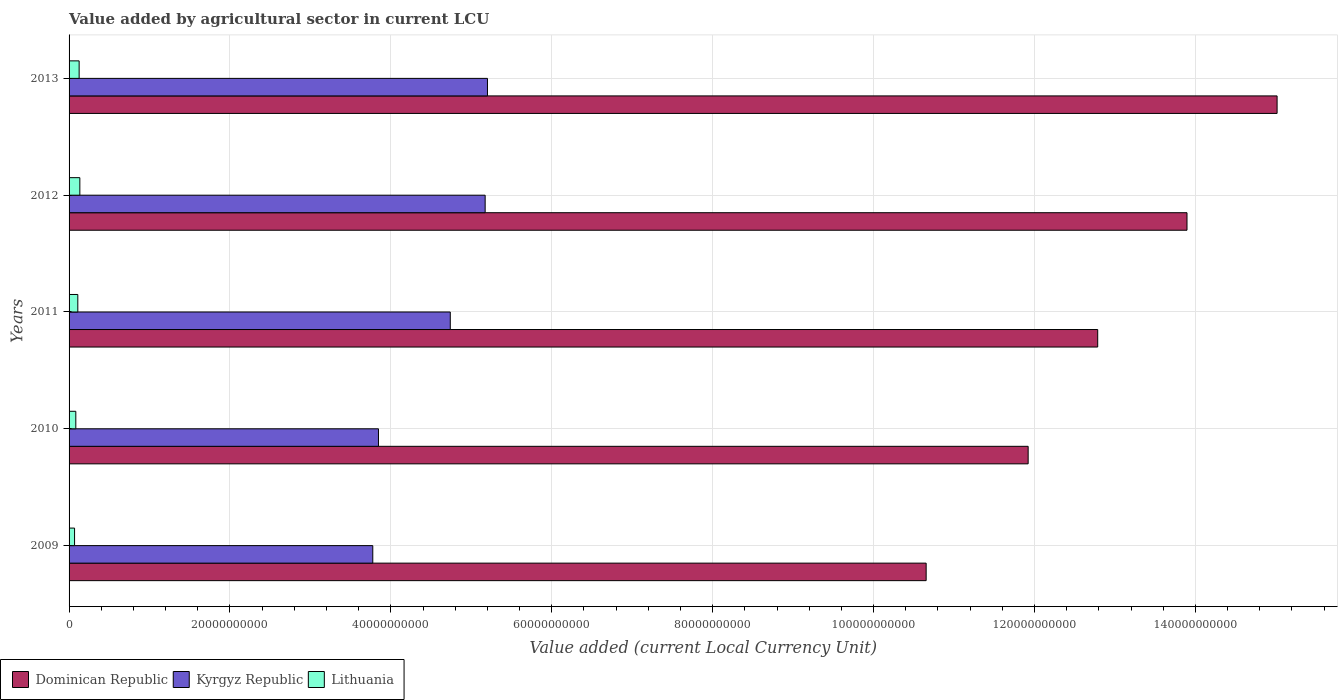How many different coloured bars are there?
Your response must be concise. 3. Are the number of bars per tick equal to the number of legend labels?
Offer a terse response. Yes. Are the number of bars on each tick of the Y-axis equal?
Make the answer very short. Yes. How many bars are there on the 4th tick from the bottom?
Your answer should be compact. 3. In how many cases, is the number of bars for a given year not equal to the number of legend labels?
Your answer should be very brief. 0. What is the value added by agricultural sector in Lithuania in 2010?
Offer a terse response. 8.38e+08. Across all years, what is the maximum value added by agricultural sector in Kyrgyz Republic?
Your answer should be compact. 5.20e+1. Across all years, what is the minimum value added by agricultural sector in Lithuania?
Provide a short and direct response. 6.82e+08. In which year was the value added by agricultural sector in Dominican Republic minimum?
Offer a very short reply. 2009. What is the total value added by agricultural sector in Dominican Republic in the graph?
Keep it short and to the point. 6.43e+11. What is the difference between the value added by agricultural sector in Dominican Republic in 2010 and that in 2011?
Your answer should be compact. -8.65e+09. What is the difference between the value added by agricultural sector in Dominican Republic in 2011 and the value added by agricultural sector in Lithuania in 2013?
Ensure brevity in your answer.  1.27e+11. What is the average value added by agricultural sector in Lithuania per year?
Provide a succinct answer. 1.04e+09. In the year 2011, what is the difference between the value added by agricultural sector in Lithuania and value added by agricultural sector in Dominican Republic?
Keep it short and to the point. -1.27e+11. What is the ratio of the value added by agricultural sector in Dominican Republic in 2011 to that in 2013?
Provide a short and direct response. 0.85. Is the value added by agricultural sector in Lithuania in 2009 less than that in 2011?
Offer a very short reply. Yes. Is the difference between the value added by agricultural sector in Lithuania in 2011 and 2012 greater than the difference between the value added by agricultural sector in Dominican Republic in 2011 and 2012?
Ensure brevity in your answer.  Yes. What is the difference between the highest and the second highest value added by agricultural sector in Kyrgyz Republic?
Provide a short and direct response. 2.88e+08. What is the difference between the highest and the lowest value added by agricultural sector in Dominican Republic?
Offer a terse response. 4.36e+1. Is the sum of the value added by agricultural sector in Dominican Republic in 2009 and 2010 greater than the maximum value added by agricultural sector in Kyrgyz Republic across all years?
Provide a succinct answer. Yes. What does the 2nd bar from the top in 2010 represents?
Give a very brief answer. Kyrgyz Republic. What does the 1st bar from the bottom in 2010 represents?
Keep it short and to the point. Dominican Republic. How many bars are there?
Your answer should be compact. 15. Are all the bars in the graph horizontal?
Provide a short and direct response. Yes. What is the difference between two consecutive major ticks on the X-axis?
Give a very brief answer. 2.00e+1. Are the values on the major ticks of X-axis written in scientific E-notation?
Offer a very short reply. No. Where does the legend appear in the graph?
Your answer should be very brief. Bottom left. What is the title of the graph?
Keep it short and to the point. Value added by agricultural sector in current LCU. Does "Switzerland" appear as one of the legend labels in the graph?
Keep it short and to the point. No. What is the label or title of the X-axis?
Your response must be concise. Value added (current Local Currency Unit). What is the label or title of the Y-axis?
Your answer should be very brief. Years. What is the Value added (current Local Currency Unit) in Dominican Republic in 2009?
Provide a short and direct response. 1.07e+11. What is the Value added (current Local Currency Unit) in Kyrgyz Republic in 2009?
Offer a very short reply. 3.78e+1. What is the Value added (current Local Currency Unit) of Lithuania in 2009?
Keep it short and to the point. 6.82e+08. What is the Value added (current Local Currency Unit) of Dominican Republic in 2010?
Make the answer very short. 1.19e+11. What is the Value added (current Local Currency Unit) of Kyrgyz Republic in 2010?
Your answer should be compact. 3.85e+1. What is the Value added (current Local Currency Unit) of Lithuania in 2010?
Offer a very short reply. 8.38e+08. What is the Value added (current Local Currency Unit) of Dominican Republic in 2011?
Give a very brief answer. 1.28e+11. What is the Value added (current Local Currency Unit) in Kyrgyz Republic in 2011?
Your answer should be compact. 4.74e+1. What is the Value added (current Local Currency Unit) of Lithuania in 2011?
Your answer should be compact. 1.09e+09. What is the Value added (current Local Currency Unit) in Dominican Republic in 2012?
Provide a short and direct response. 1.39e+11. What is the Value added (current Local Currency Unit) of Kyrgyz Republic in 2012?
Make the answer very short. 5.17e+1. What is the Value added (current Local Currency Unit) of Lithuania in 2012?
Ensure brevity in your answer.  1.34e+09. What is the Value added (current Local Currency Unit) in Dominican Republic in 2013?
Ensure brevity in your answer.  1.50e+11. What is the Value added (current Local Currency Unit) of Kyrgyz Republic in 2013?
Keep it short and to the point. 5.20e+1. What is the Value added (current Local Currency Unit) of Lithuania in 2013?
Ensure brevity in your answer.  1.25e+09. Across all years, what is the maximum Value added (current Local Currency Unit) of Dominican Republic?
Offer a terse response. 1.50e+11. Across all years, what is the maximum Value added (current Local Currency Unit) of Kyrgyz Republic?
Offer a terse response. 5.20e+1. Across all years, what is the maximum Value added (current Local Currency Unit) in Lithuania?
Offer a terse response. 1.34e+09. Across all years, what is the minimum Value added (current Local Currency Unit) of Dominican Republic?
Offer a terse response. 1.07e+11. Across all years, what is the minimum Value added (current Local Currency Unit) in Kyrgyz Republic?
Ensure brevity in your answer.  3.78e+1. Across all years, what is the minimum Value added (current Local Currency Unit) in Lithuania?
Your answer should be compact. 6.82e+08. What is the total Value added (current Local Currency Unit) of Dominican Republic in the graph?
Provide a succinct answer. 6.43e+11. What is the total Value added (current Local Currency Unit) of Kyrgyz Republic in the graph?
Make the answer very short. 2.27e+11. What is the total Value added (current Local Currency Unit) in Lithuania in the graph?
Make the answer very short. 5.20e+09. What is the difference between the Value added (current Local Currency Unit) in Dominican Republic in 2009 and that in 2010?
Offer a very short reply. -1.27e+1. What is the difference between the Value added (current Local Currency Unit) in Kyrgyz Republic in 2009 and that in 2010?
Your answer should be very brief. -7.08e+08. What is the difference between the Value added (current Local Currency Unit) of Lithuania in 2009 and that in 2010?
Provide a succinct answer. -1.56e+08. What is the difference between the Value added (current Local Currency Unit) in Dominican Republic in 2009 and that in 2011?
Your answer should be compact. -2.13e+1. What is the difference between the Value added (current Local Currency Unit) of Kyrgyz Republic in 2009 and that in 2011?
Your response must be concise. -9.63e+09. What is the difference between the Value added (current Local Currency Unit) of Lithuania in 2009 and that in 2011?
Provide a succinct answer. -4.04e+08. What is the difference between the Value added (current Local Currency Unit) in Dominican Republic in 2009 and that in 2012?
Offer a very short reply. -3.24e+1. What is the difference between the Value added (current Local Currency Unit) in Kyrgyz Republic in 2009 and that in 2012?
Make the answer very short. -1.40e+1. What is the difference between the Value added (current Local Currency Unit) of Lithuania in 2009 and that in 2012?
Give a very brief answer. -6.58e+08. What is the difference between the Value added (current Local Currency Unit) of Dominican Republic in 2009 and that in 2013?
Your response must be concise. -4.36e+1. What is the difference between the Value added (current Local Currency Unit) in Kyrgyz Republic in 2009 and that in 2013?
Your response must be concise. -1.43e+1. What is the difference between the Value added (current Local Currency Unit) of Lithuania in 2009 and that in 2013?
Your answer should be compact. -5.69e+08. What is the difference between the Value added (current Local Currency Unit) in Dominican Republic in 2010 and that in 2011?
Make the answer very short. -8.65e+09. What is the difference between the Value added (current Local Currency Unit) of Kyrgyz Republic in 2010 and that in 2011?
Give a very brief answer. -8.93e+09. What is the difference between the Value added (current Local Currency Unit) in Lithuania in 2010 and that in 2011?
Your response must be concise. -2.48e+08. What is the difference between the Value added (current Local Currency Unit) of Dominican Republic in 2010 and that in 2012?
Keep it short and to the point. -1.97e+1. What is the difference between the Value added (current Local Currency Unit) in Kyrgyz Republic in 2010 and that in 2012?
Your answer should be compact. -1.33e+1. What is the difference between the Value added (current Local Currency Unit) of Lithuania in 2010 and that in 2012?
Ensure brevity in your answer.  -5.02e+08. What is the difference between the Value added (current Local Currency Unit) of Dominican Republic in 2010 and that in 2013?
Make the answer very short. -3.09e+1. What is the difference between the Value added (current Local Currency Unit) of Kyrgyz Republic in 2010 and that in 2013?
Make the answer very short. -1.35e+1. What is the difference between the Value added (current Local Currency Unit) of Lithuania in 2010 and that in 2013?
Give a very brief answer. -4.13e+08. What is the difference between the Value added (current Local Currency Unit) of Dominican Republic in 2011 and that in 2012?
Keep it short and to the point. -1.11e+1. What is the difference between the Value added (current Local Currency Unit) of Kyrgyz Republic in 2011 and that in 2012?
Give a very brief answer. -4.33e+09. What is the difference between the Value added (current Local Currency Unit) in Lithuania in 2011 and that in 2012?
Give a very brief answer. -2.53e+08. What is the difference between the Value added (current Local Currency Unit) in Dominican Republic in 2011 and that in 2013?
Offer a very short reply. -2.23e+1. What is the difference between the Value added (current Local Currency Unit) in Kyrgyz Republic in 2011 and that in 2013?
Your answer should be compact. -4.62e+09. What is the difference between the Value added (current Local Currency Unit) in Lithuania in 2011 and that in 2013?
Your answer should be very brief. -1.65e+08. What is the difference between the Value added (current Local Currency Unit) of Dominican Republic in 2012 and that in 2013?
Your response must be concise. -1.12e+1. What is the difference between the Value added (current Local Currency Unit) of Kyrgyz Republic in 2012 and that in 2013?
Give a very brief answer. -2.88e+08. What is the difference between the Value added (current Local Currency Unit) of Lithuania in 2012 and that in 2013?
Your answer should be compact. 8.86e+07. What is the difference between the Value added (current Local Currency Unit) of Dominican Republic in 2009 and the Value added (current Local Currency Unit) of Kyrgyz Republic in 2010?
Give a very brief answer. 6.81e+1. What is the difference between the Value added (current Local Currency Unit) in Dominican Republic in 2009 and the Value added (current Local Currency Unit) in Lithuania in 2010?
Your answer should be compact. 1.06e+11. What is the difference between the Value added (current Local Currency Unit) in Kyrgyz Republic in 2009 and the Value added (current Local Currency Unit) in Lithuania in 2010?
Keep it short and to the point. 3.69e+1. What is the difference between the Value added (current Local Currency Unit) in Dominican Republic in 2009 and the Value added (current Local Currency Unit) in Kyrgyz Republic in 2011?
Ensure brevity in your answer.  5.92e+1. What is the difference between the Value added (current Local Currency Unit) in Dominican Republic in 2009 and the Value added (current Local Currency Unit) in Lithuania in 2011?
Your answer should be compact. 1.05e+11. What is the difference between the Value added (current Local Currency Unit) in Kyrgyz Republic in 2009 and the Value added (current Local Currency Unit) in Lithuania in 2011?
Make the answer very short. 3.67e+1. What is the difference between the Value added (current Local Currency Unit) of Dominican Republic in 2009 and the Value added (current Local Currency Unit) of Kyrgyz Republic in 2012?
Provide a short and direct response. 5.48e+1. What is the difference between the Value added (current Local Currency Unit) in Dominican Republic in 2009 and the Value added (current Local Currency Unit) in Lithuania in 2012?
Make the answer very short. 1.05e+11. What is the difference between the Value added (current Local Currency Unit) in Kyrgyz Republic in 2009 and the Value added (current Local Currency Unit) in Lithuania in 2012?
Your response must be concise. 3.64e+1. What is the difference between the Value added (current Local Currency Unit) of Dominican Republic in 2009 and the Value added (current Local Currency Unit) of Kyrgyz Republic in 2013?
Your answer should be very brief. 5.45e+1. What is the difference between the Value added (current Local Currency Unit) in Dominican Republic in 2009 and the Value added (current Local Currency Unit) in Lithuania in 2013?
Provide a succinct answer. 1.05e+11. What is the difference between the Value added (current Local Currency Unit) in Kyrgyz Republic in 2009 and the Value added (current Local Currency Unit) in Lithuania in 2013?
Ensure brevity in your answer.  3.65e+1. What is the difference between the Value added (current Local Currency Unit) of Dominican Republic in 2010 and the Value added (current Local Currency Unit) of Kyrgyz Republic in 2011?
Offer a terse response. 7.18e+1. What is the difference between the Value added (current Local Currency Unit) in Dominican Republic in 2010 and the Value added (current Local Currency Unit) in Lithuania in 2011?
Offer a terse response. 1.18e+11. What is the difference between the Value added (current Local Currency Unit) of Kyrgyz Republic in 2010 and the Value added (current Local Currency Unit) of Lithuania in 2011?
Give a very brief answer. 3.74e+1. What is the difference between the Value added (current Local Currency Unit) in Dominican Republic in 2010 and the Value added (current Local Currency Unit) in Kyrgyz Republic in 2012?
Ensure brevity in your answer.  6.75e+1. What is the difference between the Value added (current Local Currency Unit) of Dominican Republic in 2010 and the Value added (current Local Currency Unit) of Lithuania in 2012?
Your answer should be compact. 1.18e+11. What is the difference between the Value added (current Local Currency Unit) in Kyrgyz Republic in 2010 and the Value added (current Local Currency Unit) in Lithuania in 2012?
Offer a terse response. 3.71e+1. What is the difference between the Value added (current Local Currency Unit) in Dominican Republic in 2010 and the Value added (current Local Currency Unit) in Kyrgyz Republic in 2013?
Offer a terse response. 6.72e+1. What is the difference between the Value added (current Local Currency Unit) of Dominican Republic in 2010 and the Value added (current Local Currency Unit) of Lithuania in 2013?
Provide a short and direct response. 1.18e+11. What is the difference between the Value added (current Local Currency Unit) of Kyrgyz Republic in 2010 and the Value added (current Local Currency Unit) of Lithuania in 2013?
Your answer should be compact. 3.72e+1. What is the difference between the Value added (current Local Currency Unit) in Dominican Republic in 2011 and the Value added (current Local Currency Unit) in Kyrgyz Republic in 2012?
Keep it short and to the point. 7.61e+1. What is the difference between the Value added (current Local Currency Unit) of Dominican Republic in 2011 and the Value added (current Local Currency Unit) of Lithuania in 2012?
Your response must be concise. 1.27e+11. What is the difference between the Value added (current Local Currency Unit) in Kyrgyz Republic in 2011 and the Value added (current Local Currency Unit) in Lithuania in 2012?
Your answer should be compact. 4.60e+1. What is the difference between the Value added (current Local Currency Unit) in Dominican Republic in 2011 and the Value added (current Local Currency Unit) in Kyrgyz Republic in 2013?
Ensure brevity in your answer.  7.59e+1. What is the difference between the Value added (current Local Currency Unit) in Dominican Republic in 2011 and the Value added (current Local Currency Unit) in Lithuania in 2013?
Offer a very short reply. 1.27e+11. What is the difference between the Value added (current Local Currency Unit) in Kyrgyz Republic in 2011 and the Value added (current Local Currency Unit) in Lithuania in 2013?
Make the answer very short. 4.61e+1. What is the difference between the Value added (current Local Currency Unit) in Dominican Republic in 2012 and the Value added (current Local Currency Unit) in Kyrgyz Republic in 2013?
Offer a very short reply. 8.70e+1. What is the difference between the Value added (current Local Currency Unit) in Dominican Republic in 2012 and the Value added (current Local Currency Unit) in Lithuania in 2013?
Make the answer very short. 1.38e+11. What is the difference between the Value added (current Local Currency Unit) of Kyrgyz Republic in 2012 and the Value added (current Local Currency Unit) of Lithuania in 2013?
Your answer should be compact. 5.05e+1. What is the average Value added (current Local Currency Unit) of Dominican Republic per year?
Provide a short and direct response. 1.29e+11. What is the average Value added (current Local Currency Unit) of Kyrgyz Republic per year?
Offer a very short reply. 4.55e+1. What is the average Value added (current Local Currency Unit) of Lithuania per year?
Provide a short and direct response. 1.04e+09. In the year 2009, what is the difference between the Value added (current Local Currency Unit) in Dominican Republic and Value added (current Local Currency Unit) in Kyrgyz Republic?
Your answer should be compact. 6.88e+1. In the year 2009, what is the difference between the Value added (current Local Currency Unit) in Dominican Republic and Value added (current Local Currency Unit) in Lithuania?
Your answer should be very brief. 1.06e+11. In the year 2009, what is the difference between the Value added (current Local Currency Unit) in Kyrgyz Republic and Value added (current Local Currency Unit) in Lithuania?
Provide a short and direct response. 3.71e+1. In the year 2010, what is the difference between the Value added (current Local Currency Unit) of Dominican Republic and Value added (current Local Currency Unit) of Kyrgyz Republic?
Offer a terse response. 8.08e+1. In the year 2010, what is the difference between the Value added (current Local Currency Unit) in Dominican Republic and Value added (current Local Currency Unit) in Lithuania?
Give a very brief answer. 1.18e+11. In the year 2010, what is the difference between the Value added (current Local Currency Unit) of Kyrgyz Republic and Value added (current Local Currency Unit) of Lithuania?
Provide a succinct answer. 3.76e+1. In the year 2011, what is the difference between the Value added (current Local Currency Unit) of Dominican Republic and Value added (current Local Currency Unit) of Kyrgyz Republic?
Your answer should be very brief. 8.05e+1. In the year 2011, what is the difference between the Value added (current Local Currency Unit) in Dominican Republic and Value added (current Local Currency Unit) in Lithuania?
Make the answer very short. 1.27e+11. In the year 2011, what is the difference between the Value added (current Local Currency Unit) of Kyrgyz Republic and Value added (current Local Currency Unit) of Lithuania?
Give a very brief answer. 4.63e+1. In the year 2012, what is the difference between the Value added (current Local Currency Unit) in Dominican Republic and Value added (current Local Currency Unit) in Kyrgyz Republic?
Ensure brevity in your answer.  8.72e+1. In the year 2012, what is the difference between the Value added (current Local Currency Unit) in Dominican Republic and Value added (current Local Currency Unit) in Lithuania?
Keep it short and to the point. 1.38e+11. In the year 2012, what is the difference between the Value added (current Local Currency Unit) of Kyrgyz Republic and Value added (current Local Currency Unit) of Lithuania?
Provide a succinct answer. 5.04e+1. In the year 2013, what is the difference between the Value added (current Local Currency Unit) of Dominican Republic and Value added (current Local Currency Unit) of Kyrgyz Republic?
Your answer should be very brief. 9.82e+1. In the year 2013, what is the difference between the Value added (current Local Currency Unit) in Dominican Republic and Value added (current Local Currency Unit) in Lithuania?
Provide a succinct answer. 1.49e+11. In the year 2013, what is the difference between the Value added (current Local Currency Unit) of Kyrgyz Republic and Value added (current Local Currency Unit) of Lithuania?
Provide a succinct answer. 5.08e+1. What is the ratio of the Value added (current Local Currency Unit) in Dominican Republic in 2009 to that in 2010?
Provide a succinct answer. 0.89. What is the ratio of the Value added (current Local Currency Unit) of Kyrgyz Republic in 2009 to that in 2010?
Ensure brevity in your answer.  0.98. What is the ratio of the Value added (current Local Currency Unit) in Lithuania in 2009 to that in 2010?
Provide a short and direct response. 0.81. What is the ratio of the Value added (current Local Currency Unit) of Dominican Republic in 2009 to that in 2011?
Your answer should be compact. 0.83. What is the ratio of the Value added (current Local Currency Unit) of Kyrgyz Republic in 2009 to that in 2011?
Your response must be concise. 0.8. What is the ratio of the Value added (current Local Currency Unit) in Lithuania in 2009 to that in 2011?
Provide a succinct answer. 0.63. What is the ratio of the Value added (current Local Currency Unit) in Dominican Republic in 2009 to that in 2012?
Your answer should be very brief. 0.77. What is the ratio of the Value added (current Local Currency Unit) in Kyrgyz Republic in 2009 to that in 2012?
Your answer should be compact. 0.73. What is the ratio of the Value added (current Local Currency Unit) of Lithuania in 2009 to that in 2012?
Provide a succinct answer. 0.51. What is the ratio of the Value added (current Local Currency Unit) in Dominican Republic in 2009 to that in 2013?
Keep it short and to the point. 0.71. What is the ratio of the Value added (current Local Currency Unit) in Kyrgyz Republic in 2009 to that in 2013?
Your answer should be compact. 0.73. What is the ratio of the Value added (current Local Currency Unit) of Lithuania in 2009 to that in 2013?
Your answer should be very brief. 0.55. What is the ratio of the Value added (current Local Currency Unit) in Dominican Republic in 2010 to that in 2011?
Your answer should be very brief. 0.93. What is the ratio of the Value added (current Local Currency Unit) of Kyrgyz Republic in 2010 to that in 2011?
Make the answer very short. 0.81. What is the ratio of the Value added (current Local Currency Unit) in Lithuania in 2010 to that in 2011?
Provide a short and direct response. 0.77. What is the ratio of the Value added (current Local Currency Unit) in Dominican Republic in 2010 to that in 2012?
Keep it short and to the point. 0.86. What is the ratio of the Value added (current Local Currency Unit) of Kyrgyz Republic in 2010 to that in 2012?
Offer a very short reply. 0.74. What is the ratio of the Value added (current Local Currency Unit) of Lithuania in 2010 to that in 2012?
Your answer should be very brief. 0.63. What is the ratio of the Value added (current Local Currency Unit) of Dominican Republic in 2010 to that in 2013?
Provide a succinct answer. 0.79. What is the ratio of the Value added (current Local Currency Unit) in Kyrgyz Republic in 2010 to that in 2013?
Offer a terse response. 0.74. What is the ratio of the Value added (current Local Currency Unit) of Lithuania in 2010 to that in 2013?
Ensure brevity in your answer.  0.67. What is the ratio of the Value added (current Local Currency Unit) of Dominican Republic in 2011 to that in 2012?
Make the answer very short. 0.92. What is the ratio of the Value added (current Local Currency Unit) of Kyrgyz Republic in 2011 to that in 2012?
Offer a very short reply. 0.92. What is the ratio of the Value added (current Local Currency Unit) of Lithuania in 2011 to that in 2012?
Your answer should be compact. 0.81. What is the ratio of the Value added (current Local Currency Unit) of Dominican Republic in 2011 to that in 2013?
Your answer should be compact. 0.85. What is the ratio of the Value added (current Local Currency Unit) in Kyrgyz Republic in 2011 to that in 2013?
Make the answer very short. 0.91. What is the ratio of the Value added (current Local Currency Unit) in Lithuania in 2011 to that in 2013?
Keep it short and to the point. 0.87. What is the ratio of the Value added (current Local Currency Unit) of Dominican Republic in 2012 to that in 2013?
Give a very brief answer. 0.93. What is the ratio of the Value added (current Local Currency Unit) of Kyrgyz Republic in 2012 to that in 2013?
Give a very brief answer. 0.99. What is the ratio of the Value added (current Local Currency Unit) of Lithuania in 2012 to that in 2013?
Keep it short and to the point. 1.07. What is the difference between the highest and the second highest Value added (current Local Currency Unit) of Dominican Republic?
Ensure brevity in your answer.  1.12e+1. What is the difference between the highest and the second highest Value added (current Local Currency Unit) in Kyrgyz Republic?
Make the answer very short. 2.88e+08. What is the difference between the highest and the second highest Value added (current Local Currency Unit) of Lithuania?
Provide a short and direct response. 8.86e+07. What is the difference between the highest and the lowest Value added (current Local Currency Unit) in Dominican Republic?
Offer a terse response. 4.36e+1. What is the difference between the highest and the lowest Value added (current Local Currency Unit) in Kyrgyz Republic?
Your answer should be very brief. 1.43e+1. What is the difference between the highest and the lowest Value added (current Local Currency Unit) in Lithuania?
Give a very brief answer. 6.58e+08. 